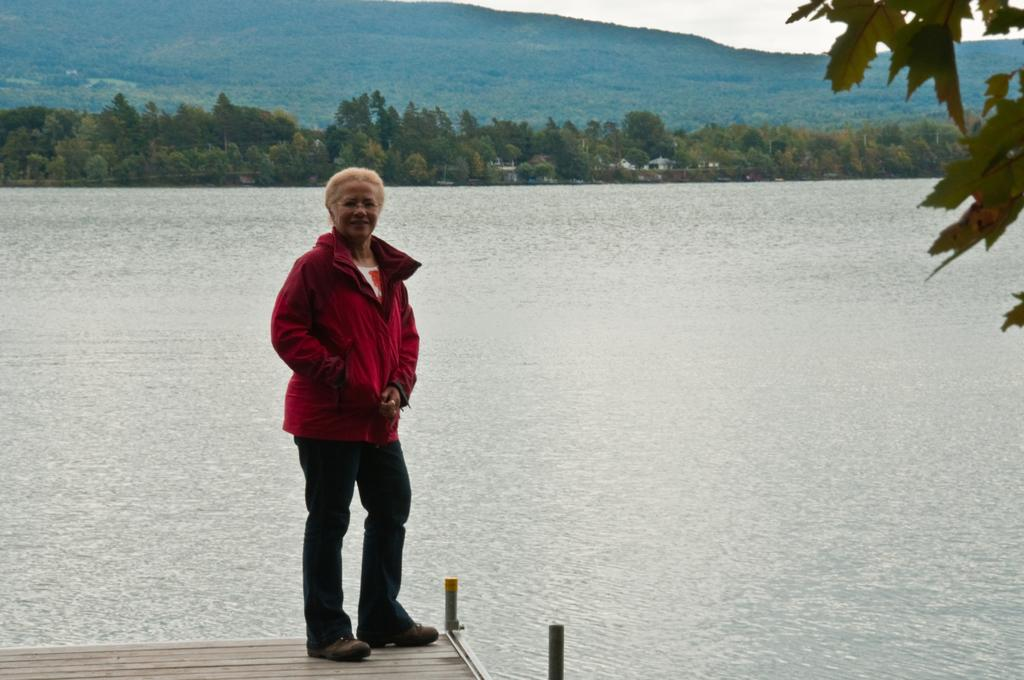What is the main subject of the image? There is a woman standing in the image. What is the woman standing on? The woman is standing on a surface. What natural element can be seen in the image? There is water visible in the image. What is present on the right side of the image? There are leaves on the right side of the image. What can be seen in the background of the image? There are trees, hills, and the sky visible in the background of the image. What type of mind-reading technique is the woman using in the image? There is no indication in the image that the woman is using any mind-reading technique. Can you tell me how many firemen are present in the image? There are no firemen present in the image. Where is the faucet located in the image? There is no faucet present in the image. 